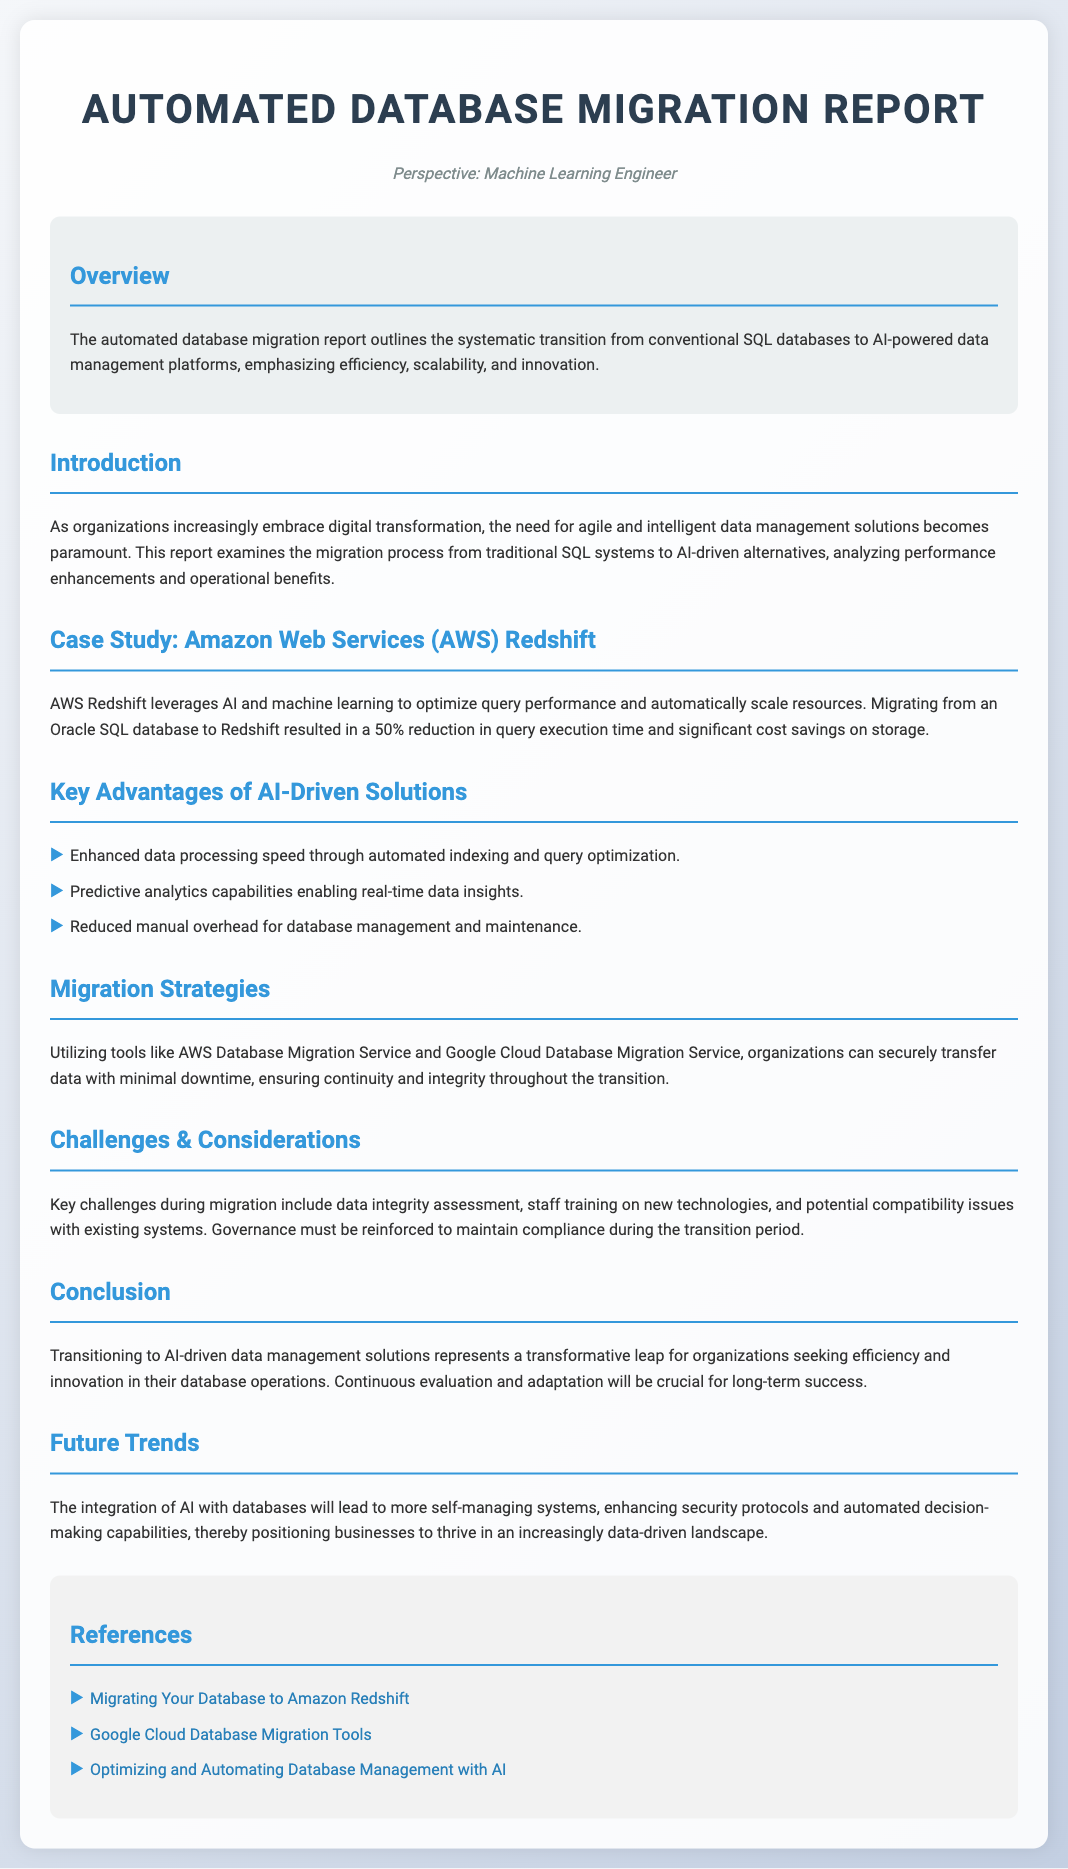What is the title of the report? The title is provided at the start of the document as "Automated Database Migration Report."
Answer: Automated Database Migration Report What case study is mentioned in the report? The report includes a case study of AWS Redshift, illustrating its migration from Oracle SQL.
Answer: AWS Redshift What is the percentage reduction in query execution time after migrating to Redshift? The report states a 50% reduction in query execution time following the migration.
Answer: 50% What tools are suggested for migration? The document mentions AWS Database Migration Service and Google Cloud Database Migration Service as tools for migration.
Answer: AWS Database Migration Service and Google Cloud Database Migration Service What is a challenge mentioned during migration? The report highlights data integrity assessment as a key challenge faced during migration.
Answer: Data integrity assessment What is one of the key advantages of AI-driven solutions? According to the report, enhanced data processing speed is a significant advantage of AI-driven solutions.
Answer: Enhanced data processing speed What is the overall perspective of the report? The perspective is specified as that of a machine learning engineer.
Answer: Machine Learning Engineer What is the conclusion about transitioning to AI-driven data management solutions? The document concludes that transitioning represents a transformative leap for organizations.
Answer: Transformative leap 